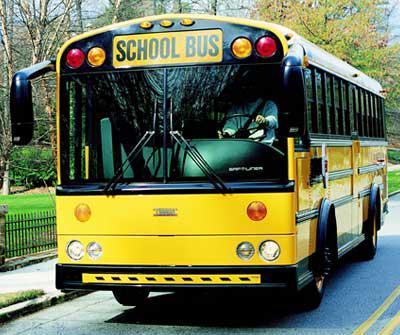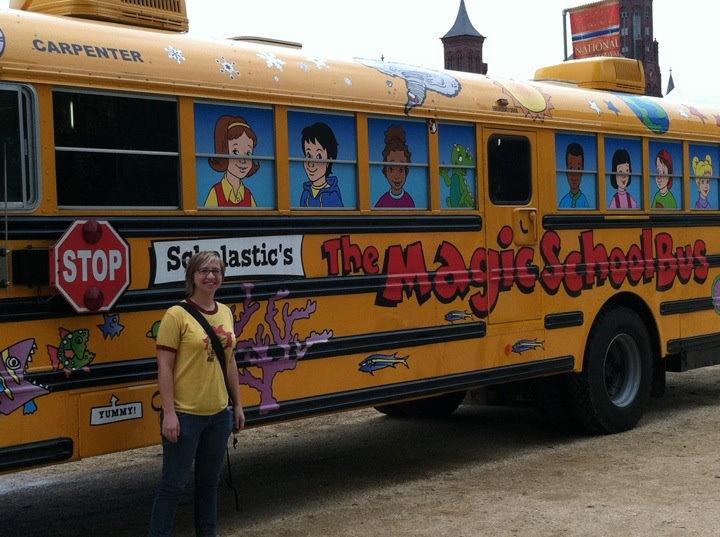The first image is the image on the left, the second image is the image on the right. Analyze the images presented: Is the assertion "An image includes a girl in jeans standing in front of a bus decorated with cartoon faces in the windows." valid? Answer yes or no. Yes. The first image is the image on the left, the second image is the image on the right. Examine the images to the left and right. Is the description "One bus is a Magic School Bus and one isn't." accurate? Answer yes or no. Yes. 